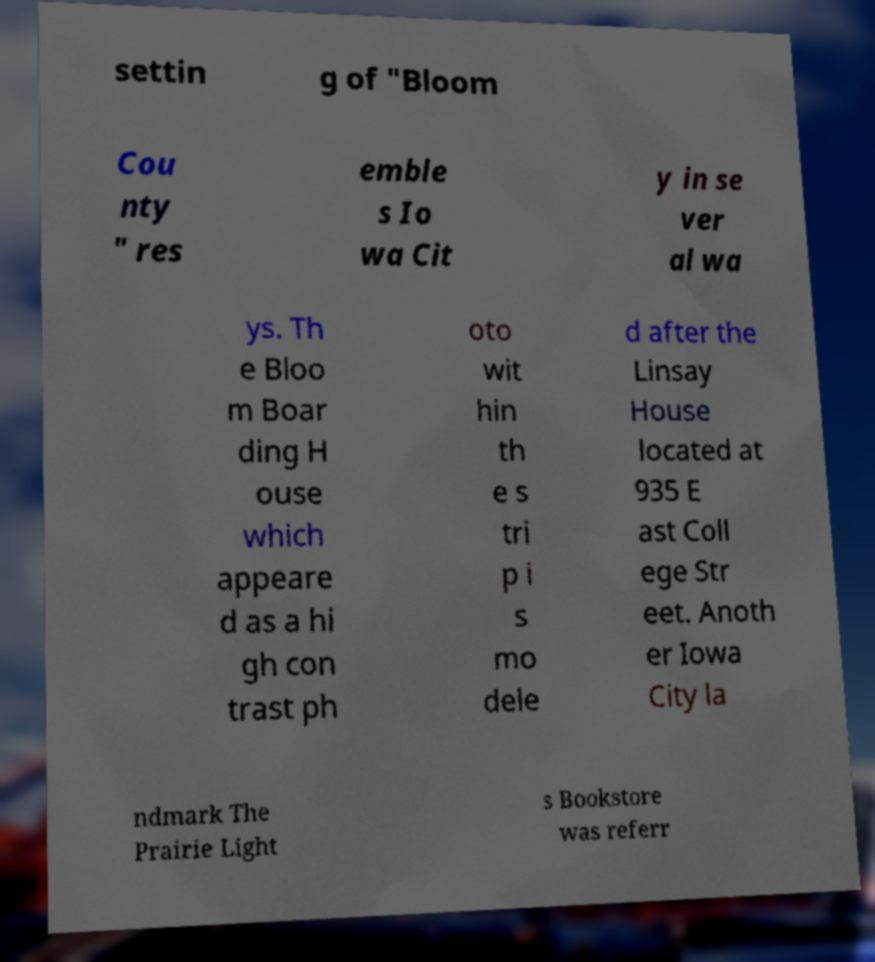Please identify and transcribe the text found in this image. settin g of "Bloom Cou nty " res emble s Io wa Cit y in se ver al wa ys. Th e Bloo m Boar ding H ouse which appeare d as a hi gh con trast ph oto wit hin th e s tri p i s mo dele d after the Linsay House located at 935 E ast Coll ege Str eet. Anoth er Iowa City la ndmark The Prairie Light s Bookstore was referr 